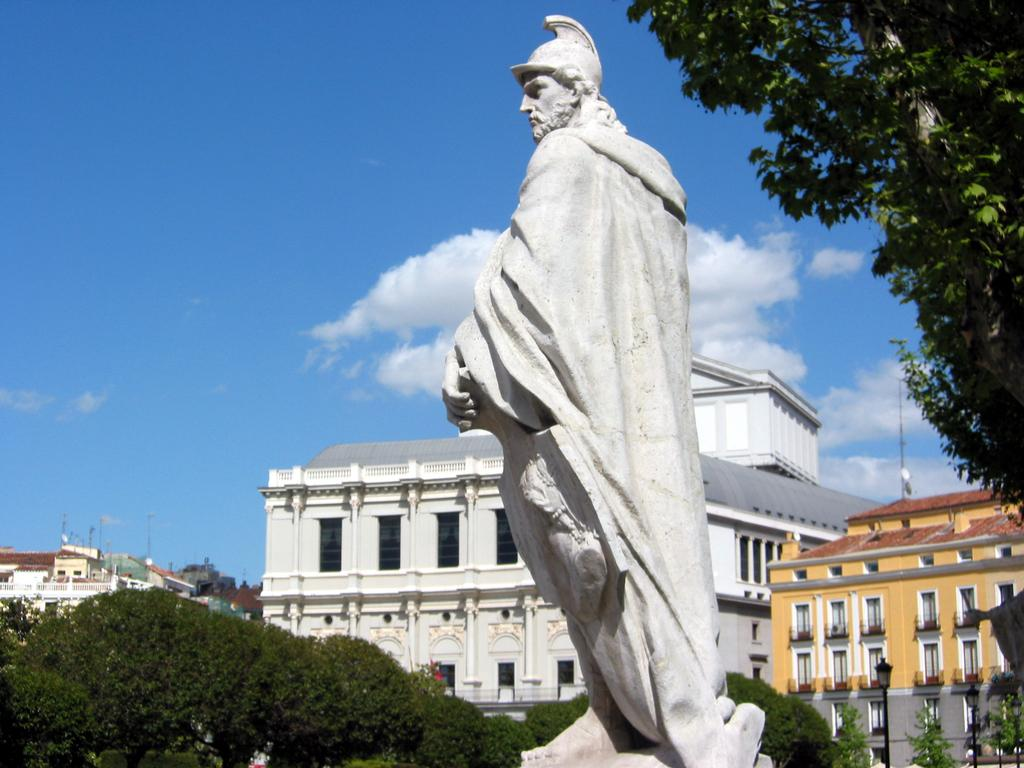What is the main subject in the image? There is a statue in the image. What other elements can be seen in the image besides the statue? There are trees, buildings with windows, and light poles in the image. What is visible in the background of the image? The sky with clouds is visible in the background of the image. Where is the chair located in the image? There is no chair present in the image. What type of flower can be seen growing in the garden in the image? There is no garden or flower present in the image. 